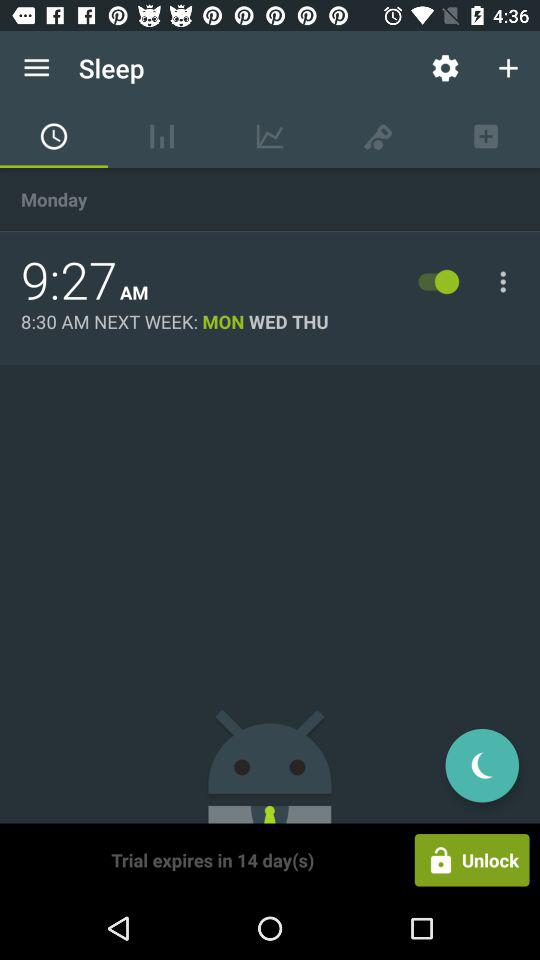How many days are left on the trial?
Answer the question using a single word or phrase. 14 